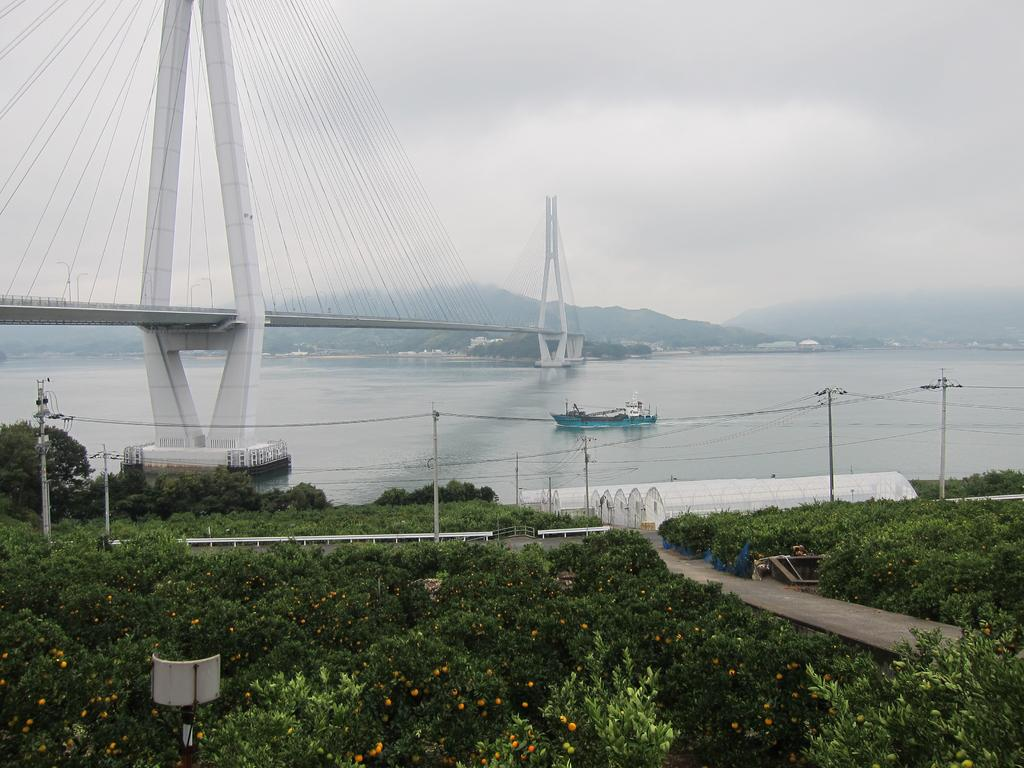What type of living organisms can be seen in the image? Plants are visible in the image. What type of structure can be seen in the image? There is a fence in the image. What type of shelter is present in the image? There are shelters in the image. What type of vertical structures can be seen in the image? There are poles in the image. What can be seen in the background of the image? There is a boat, a bridge, and buildings visible in the background of the image. What type of stamp is being used to hold the boat in place in the image? There is no stamp present in the image, and the boat is not being held in place by any visible means. What type of bait is being used to attract the fish near the boat in the image? There is no fishing activity depicted in the image, and no bait is visible. 